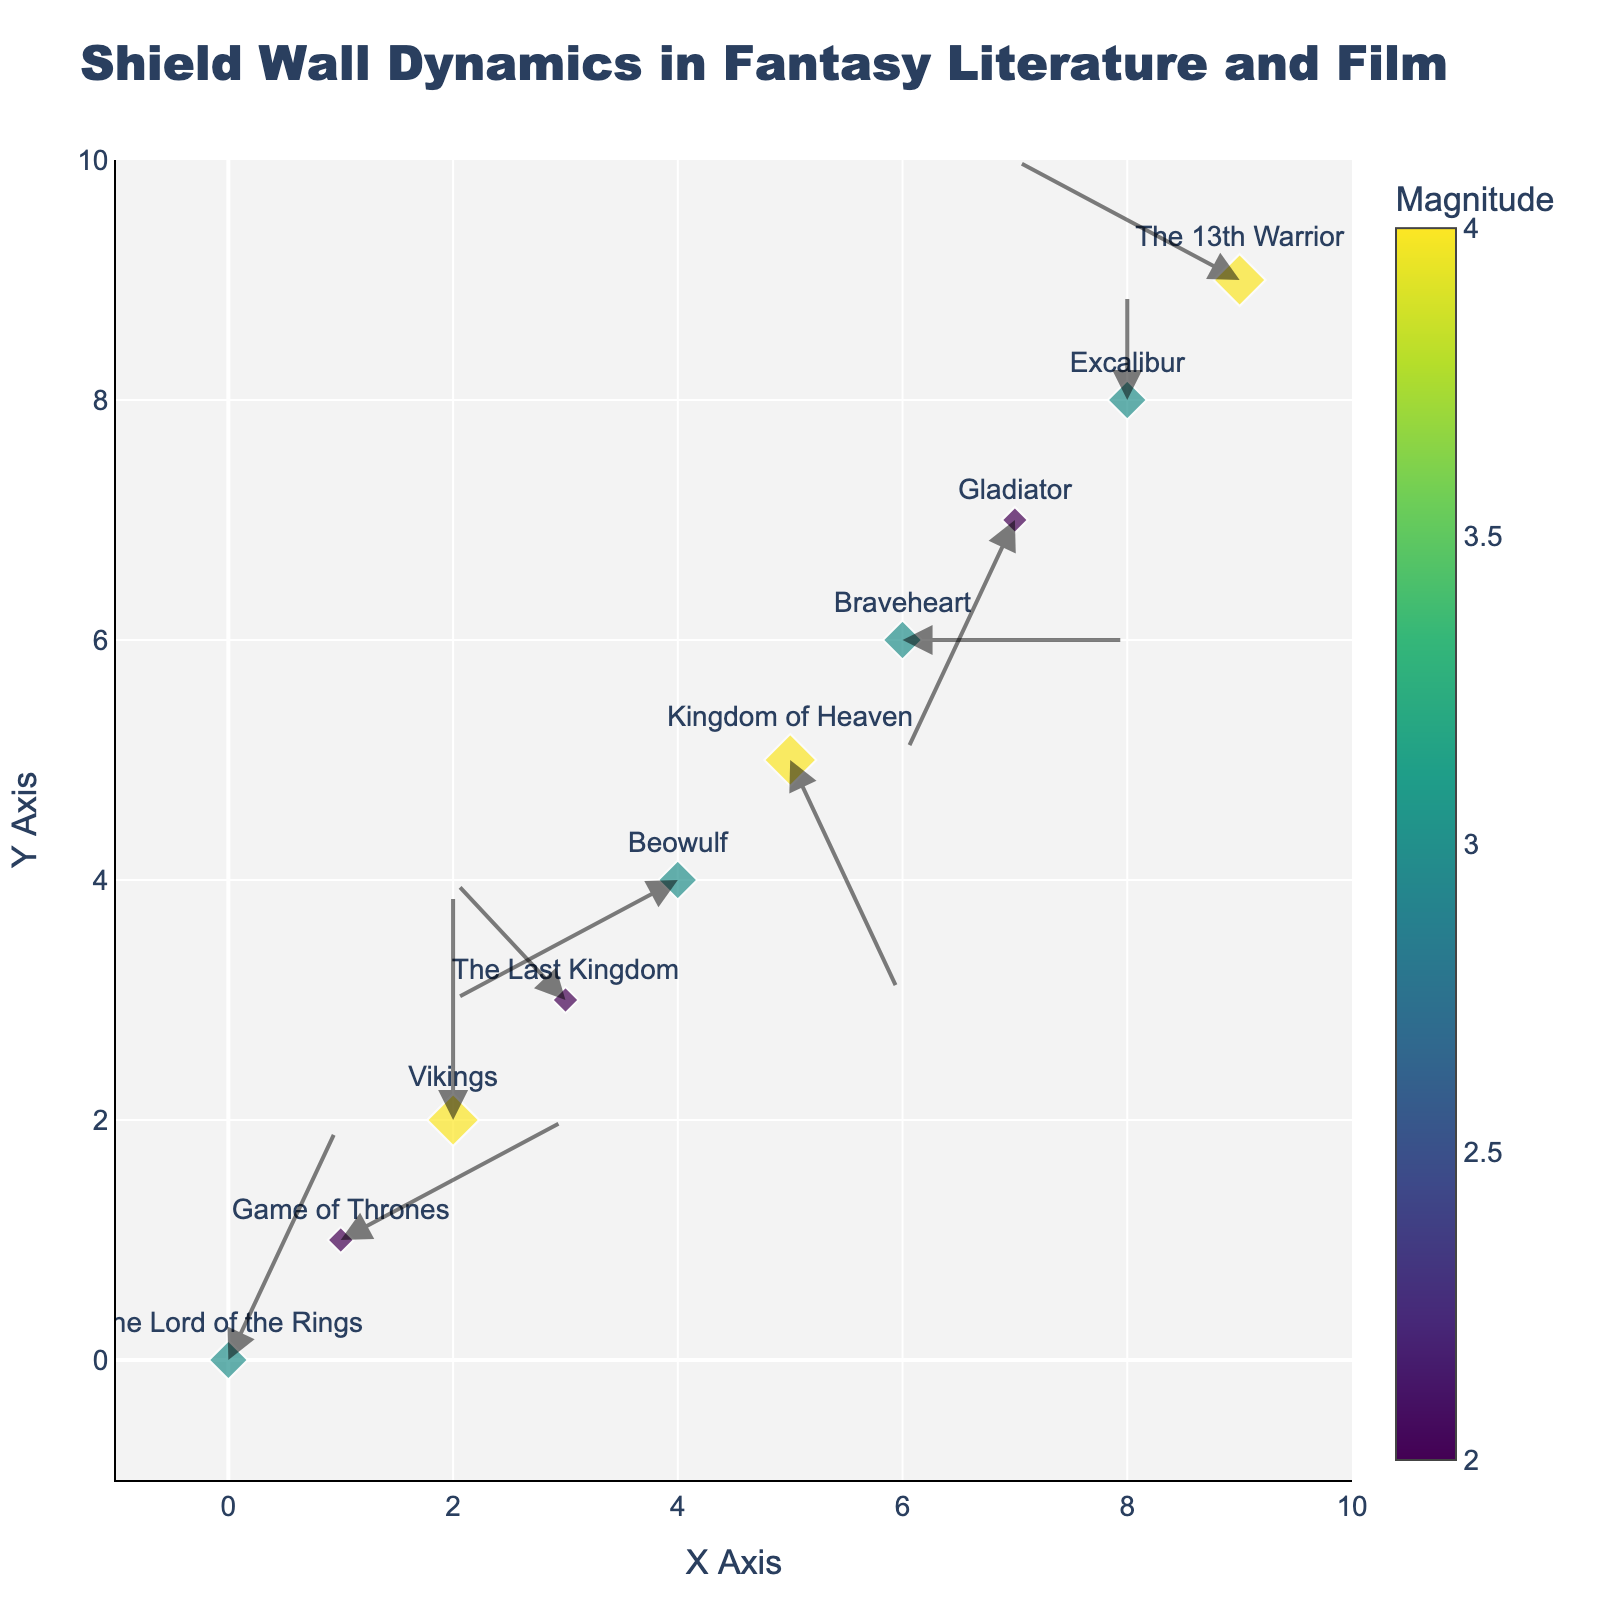what is the title of the plot? The title of the plot is displayed at the top center of the figure. It reads "Shield Wall Dynamics in Fantasy Literature and Film".
Answer: Shield Wall Dynamics in Fantasy Literature and Film How many data points are represented in the plot? There are 10 data points represented by markers with text labels in the plot.
Answer: 10 Which work has the highest magnitude? The plot uses marker size and color to indicate the magnitude. By observing the largest and darkest marker, we can see that "Vikings" has the highest magnitude of 4.
Answer: Vikings Are there any works that have arrows pointing directly upwards (v = positive, u = 0)? We need to look for arrows where the horizontal component (u) is 0 and the vertical component (v) is positive. The marker labeled "Vikings" at (2,2) has an arrow pointing directly upwards.
Answer: Vikings Which works have negative x or y components in their arrow directions? Checking the arrows, "The Last Kingdom" has a negative x component, and "Gladiator" and "Beowulf" have negative components in both x and y directions.
Answer: The Last Kingdom, Gladiator, Beowulf Which work has the longest arrow? The longest arrow corresponds to the highest magnitude, which we already identified as "Vikings". By observing the length of the arrows, it confirms that "Vikings" has the longest arrow.
Answer: Vikings What is the common theme among the works with arrows pointing negatively on the y-axis (v = negative)? Observing works such as "Kingdom of Heaven", "Gladiator", and "Beowulf", we notice their arrows point downwards. These works often depict significant battle outcomes involving losses or challenging circumstances.
Answer: Significant battle outcomes or challenging circumstances What is the range of the x-axis and y-axis? The axes show values from -1 to 10 on both the x and y axes, indicated by the axis ticks and range settings.
Answer: -1 to 10 How do the directions of the arrows (vectors) contribute to understanding shield wall dynamics in these works? Arrows in the plot indicate movement directions and dynamics of shield walls. Positive components suggest movement in respective directions, while negative components reflect opposition or retreat, which helps visualize the dynamics in battles from these works.
Answer: Indicate movement directions and dynamics in battles What general trend can you observe about the representation of movement in older vs. newer adaptations? Newer adaptations like "The Lord of the Rings" or "Game of Thrones" show more dynamic movements (arrows with both positive u and v), whereas older adaptations like "Beowulf" or "Excalibur" depict more static, linear movements.
Answer: Newer adaptations show dynamic movements, older ones depict static movements 